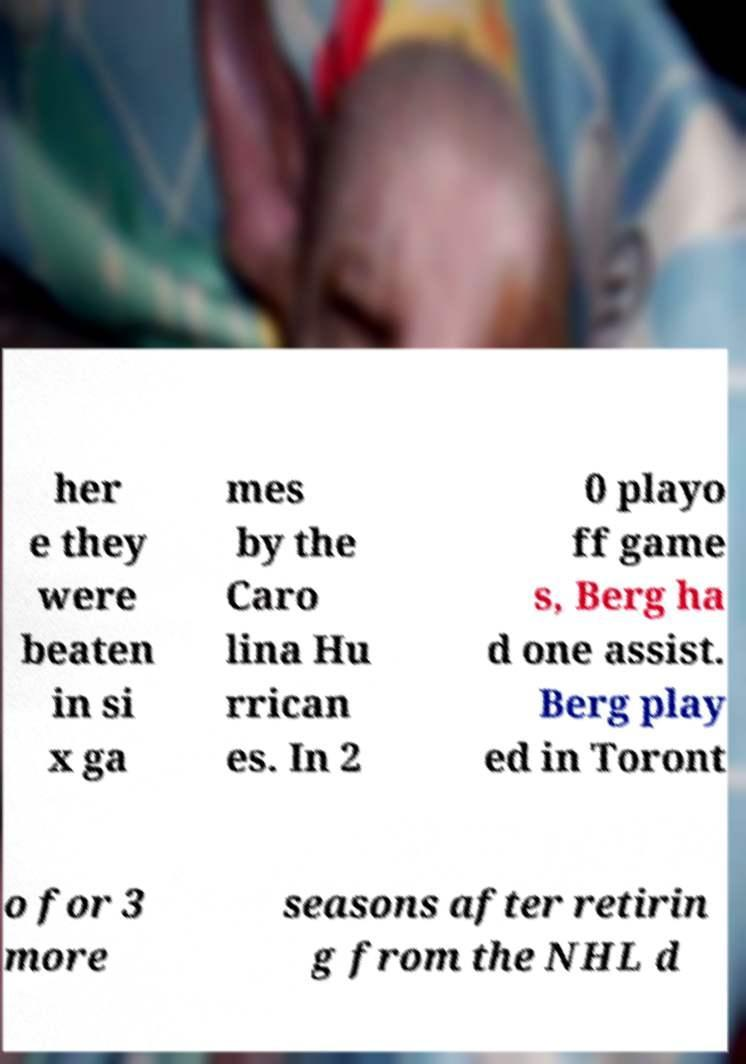For documentation purposes, I need the text within this image transcribed. Could you provide that? her e they were beaten in si x ga mes by the Caro lina Hu rrican es. In 2 0 playo ff game s, Berg ha d one assist. Berg play ed in Toront o for 3 more seasons after retirin g from the NHL d 